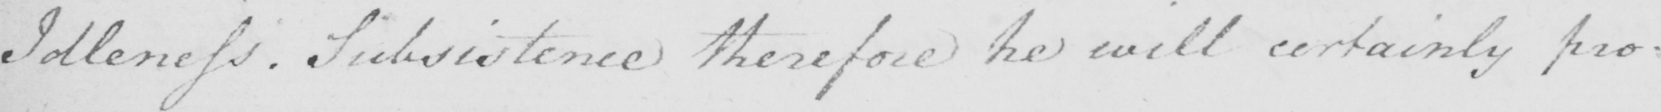What is written in this line of handwriting? Idleness . Subsistence therefore he will certainly pro : 